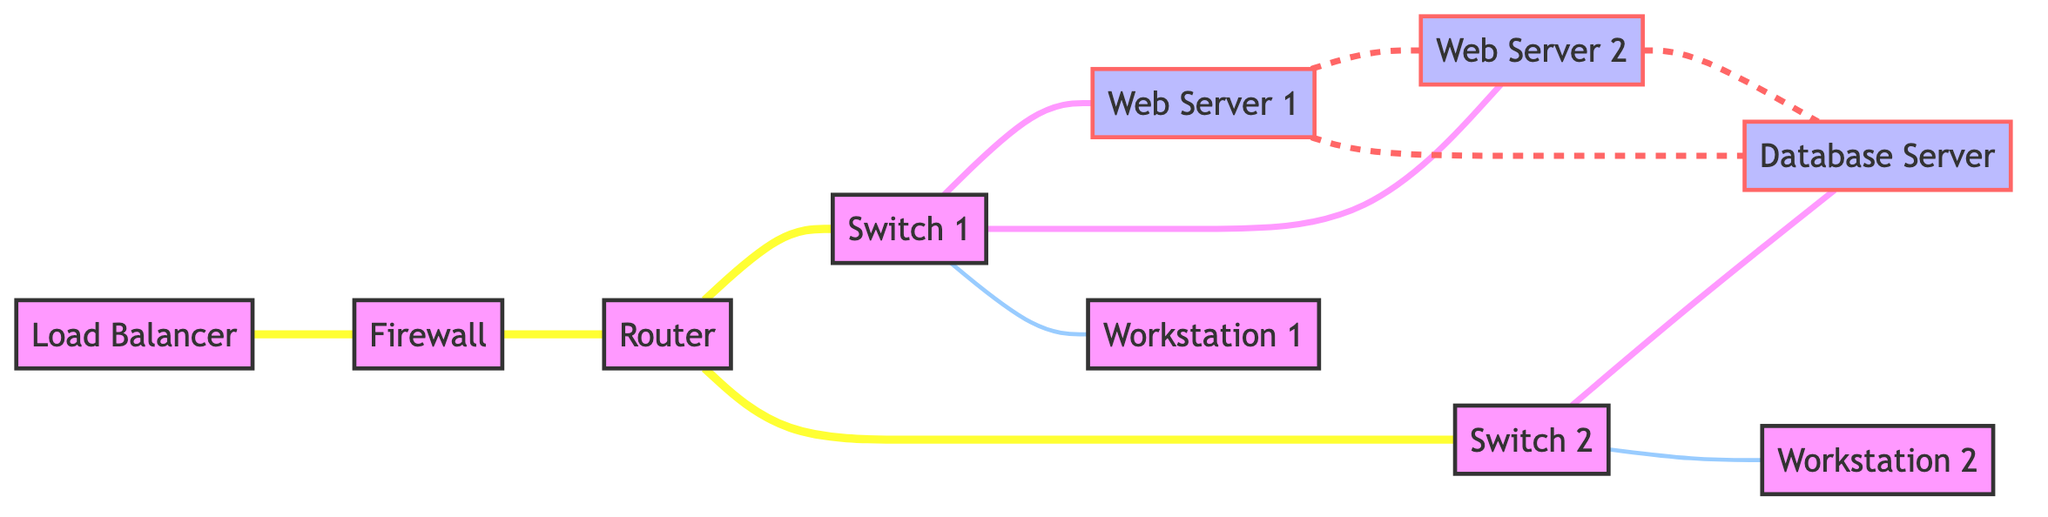What is the total number of nodes in the graph? By counting the unique entities represented as points, we have a total of 10 nodes in the diagram.
Answer: 10 How many servers are connected directly to Switch 1? Switch 1 has direct edges leading to Web Server 1 and Web Server 2, giving a total of 2 servers.
Answer: 2 Which device connects the Load Balancer to the Router? The Firewall provides the connection between the Load Balancer and the Router as per the edge defined in the diagram.
Answer: Firewall How many edges are connected to Router? The Router connects to Switch 1 and Switch 2, making for a total of 3 edges leading out from it.
Answer: 3 Which workstation is connected to Switch 2? The diagram shows that Workstation 2 has a direct connection to Switch 2, establishing a clear relationship.
Answer: Workstation 2 Are Server 1 and Server 2 directly connected? In the diagram, there exists an edge between Server 1 and Server 2, indicating a direct connection.
Answer: Yes What is the relationship between Firewall and Load Balancer? The diagram depicts a direct edge from the Load Balancer to the Firewall, establishing them as directly connected devices.
Answer: Connected Which switch connects the Database Server? Only Switch 2 shows a connection to the Database Server, as illustrated by the edge leading to it.
Answer: Switch 2 What is the maximum number of connections a server can have directly? Examining the connections, Server 1 or Server 2 can connect to up to 3 other servers, which is the maximum found in this diagram.
Answer: 3 